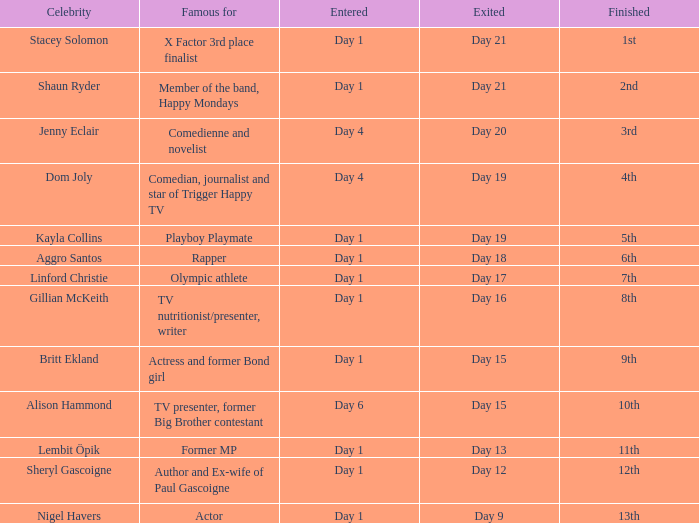Which well-known individual was celebrated for their rap career? Aggro Santos. 